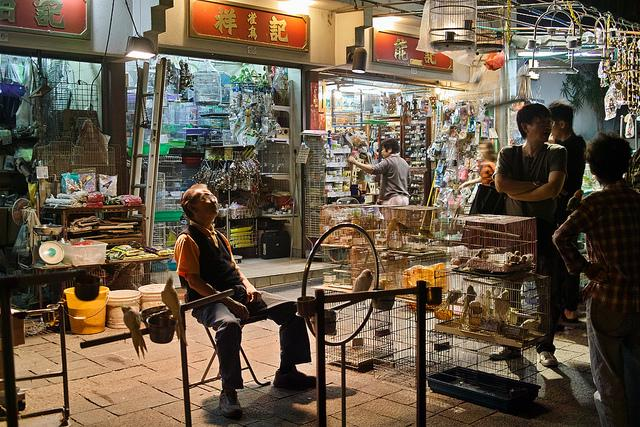The birds seen out of their cage here are sold for what purpose? Please explain your reasoning. pets. The birds are in a pet shop. 